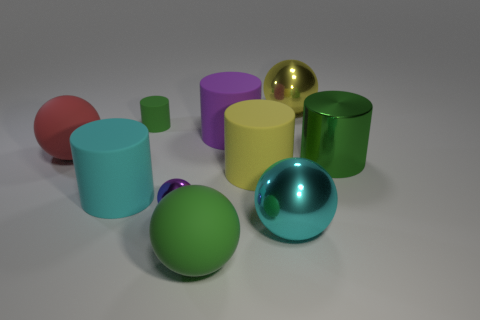Is the size of the yellow rubber thing the same as the green matte thing behind the large cyan cylinder?
Keep it short and to the point. No. What material is the yellow object in front of the big ball left of the large green object that is in front of the metal cylinder made of?
Give a very brief answer. Rubber. Is the shape of the large cyan thing on the left side of the small green object the same as the yellow rubber object to the left of the yellow sphere?
Give a very brief answer. Yes. Are there any purple rubber cylinders of the same size as the yellow matte cylinder?
Offer a very short reply. Yes. What number of green objects are either small cubes or small cylinders?
Give a very brief answer. 1. What number of big metallic objects have the same color as the small cylinder?
Make the answer very short. 1. What number of balls are either red rubber objects or cyan shiny objects?
Give a very brief answer. 2. What color is the big metal sphere in front of the yellow cylinder?
Ensure brevity in your answer.  Cyan. There is another yellow object that is the same size as the yellow rubber object; what shape is it?
Offer a very short reply. Sphere. There is a yellow rubber cylinder; what number of large rubber objects are behind it?
Keep it short and to the point. 2. 